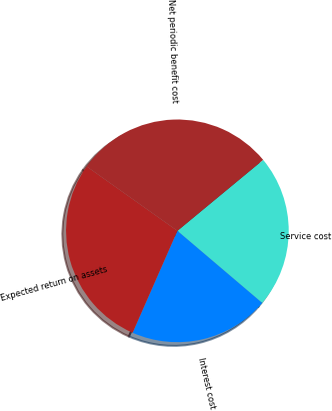<chart> <loc_0><loc_0><loc_500><loc_500><pie_chart><fcel>Service cost<fcel>Interest cost<fcel>Expected return on assets<fcel>Net periodic benefit cost<nl><fcel>22.22%<fcel>20.37%<fcel>28.24%<fcel>29.17%<nl></chart> 